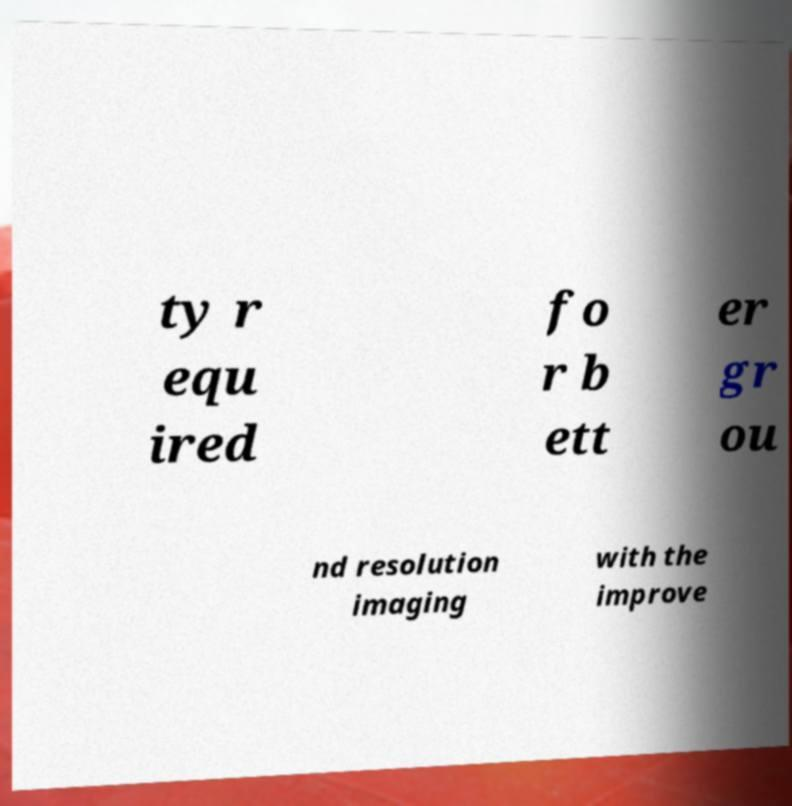Can you read and provide the text displayed in the image?This photo seems to have some interesting text. Can you extract and type it out for me? ty r equ ired fo r b ett er gr ou nd resolution imaging with the improve 